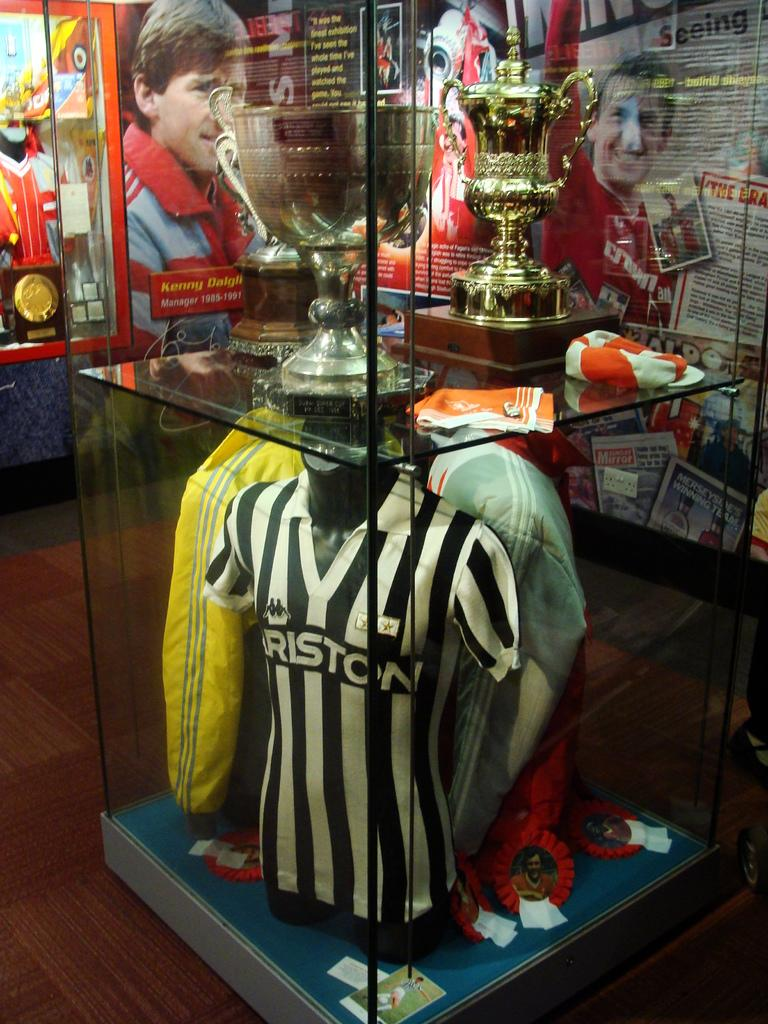What is the main object in the image? There is a glass box in the image. What items are inside the glass box? The glass box contains t-shirts, badges, and trophies. Are there any other items in the glass box? Yes, there are other unspecified things in the glass box. What can be seen in the background of the image? There are posters in the background of the image. Can you tell me how many ears of corn are displayed on the posters in the image? There is no corn displayed on the posters in the image; they only contain unspecified images or text. How many friends are visible in the image? There is no mention of friends in the image; it features a glass box with various items and posters in the background. 